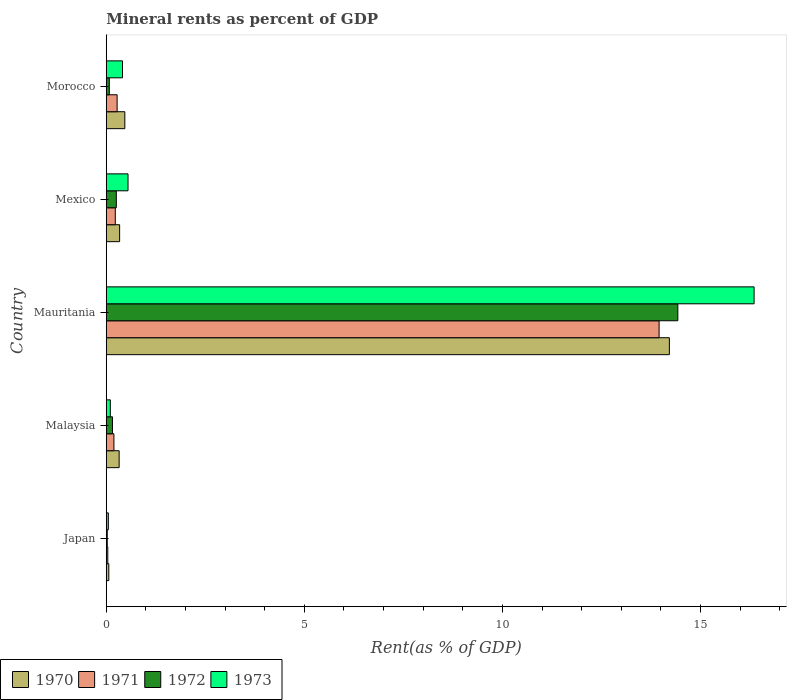How many groups of bars are there?
Offer a very short reply. 5. What is the label of the 5th group of bars from the top?
Your response must be concise. Japan. In how many cases, is the number of bars for a given country not equal to the number of legend labels?
Your response must be concise. 0. What is the mineral rent in 1970 in Japan?
Offer a very short reply. 0.06. Across all countries, what is the maximum mineral rent in 1971?
Provide a short and direct response. 13.95. Across all countries, what is the minimum mineral rent in 1972?
Offer a terse response. 0.03. In which country was the mineral rent in 1971 maximum?
Make the answer very short. Mauritania. In which country was the mineral rent in 1972 minimum?
Provide a succinct answer. Japan. What is the total mineral rent in 1971 in the graph?
Offer a terse response. 14.69. What is the difference between the mineral rent in 1970 in Mauritania and that in Morocco?
Your response must be concise. 13.74. What is the difference between the mineral rent in 1971 in Morocco and the mineral rent in 1970 in Japan?
Provide a short and direct response. 0.21. What is the average mineral rent in 1972 per country?
Provide a succinct answer. 2.99. What is the difference between the mineral rent in 1973 and mineral rent in 1972 in Mauritania?
Give a very brief answer. 1.93. In how many countries, is the mineral rent in 1972 greater than 8 %?
Provide a short and direct response. 1. What is the ratio of the mineral rent in 1972 in Malaysia to that in Morocco?
Keep it short and to the point. 2.05. What is the difference between the highest and the second highest mineral rent in 1970?
Keep it short and to the point. 13.74. What is the difference between the highest and the lowest mineral rent in 1970?
Make the answer very short. 14.15. In how many countries, is the mineral rent in 1973 greater than the average mineral rent in 1973 taken over all countries?
Provide a succinct answer. 1. Is it the case that in every country, the sum of the mineral rent in 1972 and mineral rent in 1970 is greater than the mineral rent in 1971?
Give a very brief answer. Yes. How many countries are there in the graph?
Give a very brief answer. 5. Are the values on the major ticks of X-axis written in scientific E-notation?
Offer a very short reply. No. Does the graph contain grids?
Your answer should be compact. No. How many legend labels are there?
Your answer should be very brief. 4. How are the legend labels stacked?
Provide a short and direct response. Horizontal. What is the title of the graph?
Ensure brevity in your answer.  Mineral rents as percent of GDP. What is the label or title of the X-axis?
Make the answer very short. Rent(as % of GDP). What is the label or title of the Y-axis?
Provide a short and direct response. Country. What is the Rent(as % of GDP) in 1970 in Japan?
Give a very brief answer. 0.06. What is the Rent(as % of GDP) in 1971 in Japan?
Your response must be concise. 0.04. What is the Rent(as % of GDP) in 1972 in Japan?
Offer a very short reply. 0.03. What is the Rent(as % of GDP) in 1973 in Japan?
Ensure brevity in your answer.  0.05. What is the Rent(as % of GDP) in 1970 in Malaysia?
Your answer should be very brief. 0.33. What is the Rent(as % of GDP) of 1971 in Malaysia?
Provide a succinct answer. 0.19. What is the Rent(as % of GDP) in 1972 in Malaysia?
Your answer should be very brief. 0.16. What is the Rent(as % of GDP) in 1973 in Malaysia?
Keep it short and to the point. 0.1. What is the Rent(as % of GDP) of 1970 in Mauritania?
Give a very brief answer. 14.21. What is the Rent(as % of GDP) in 1971 in Mauritania?
Your answer should be compact. 13.95. What is the Rent(as % of GDP) in 1972 in Mauritania?
Offer a terse response. 14.43. What is the Rent(as % of GDP) of 1973 in Mauritania?
Give a very brief answer. 16.35. What is the Rent(as % of GDP) in 1970 in Mexico?
Make the answer very short. 0.34. What is the Rent(as % of GDP) of 1971 in Mexico?
Offer a terse response. 0.23. What is the Rent(as % of GDP) in 1972 in Mexico?
Your answer should be compact. 0.25. What is the Rent(as % of GDP) of 1973 in Mexico?
Keep it short and to the point. 0.55. What is the Rent(as % of GDP) of 1970 in Morocco?
Your answer should be compact. 0.47. What is the Rent(as % of GDP) of 1971 in Morocco?
Provide a short and direct response. 0.27. What is the Rent(as % of GDP) of 1972 in Morocco?
Provide a short and direct response. 0.08. What is the Rent(as % of GDP) of 1973 in Morocco?
Provide a short and direct response. 0.41. Across all countries, what is the maximum Rent(as % of GDP) of 1970?
Provide a succinct answer. 14.21. Across all countries, what is the maximum Rent(as % of GDP) of 1971?
Keep it short and to the point. 13.95. Across all countries, what is the maximum Rent(as % of GDP) of 1972?
Provide a short and direct response. 14.43. Across all countries, what is the maximum Rent(as % of GDP) of 1973?
Offer a very short reply. 16.35. Across all countries, what is the minimum Rent(as % of GDP) of 1970?
Provide a succinct answer. 0.06. Across all countries, what is the minimum Rent(as % of GDP) of 1971?
Your response must be concise. 0.04. Across all countries, what is the minimum Rent(as % of GDP) in 1972?
Provide a short and direct response. 0.03. Across all countries, what is the minimum Rent(as % of GDP) in 1973?
Provide a short and direct response. 0.05. What is the total Rent(as % of GDP) of 1970 in the graph?
Provide a succinct answer. 15.41. What is the total Rent(as % of GDP) in 1971 in the graph?
Ensure brevity in your answer.  14.69. What is the total Rent(as % of GDP) in 1972 in the graph?
Make the answer very short. 14.94. What is the total Rent(as % of GDP) in 1973 in the graph?
Offer a very short reply. 17.47. What is the difference between the Rent(as % of GDP) of 1970 in Japan and that in Malaysia?
Give a very brief answer. -0.26. What is the difference between the Rent(as % of GDP) of 1971 in Japan and that in Malaysia?
Make the answer very short. -0.16. What is the difference between the Rent(as % of GDP) in 1972 in Japan and that in Malaysia?
Your answer should be very brief. -0.13. What is the difference between the Rent(as % of GDP) of 1973 in Japan and that in Malaysia?
Your answer should be very brief. -0.05. What is the difference between the Rent(as % of GDP) in 1970 in Japan and that in Mauritania?
Offer a terse response. -14.15. What is the difference between the Rent(as % of GDP) in 1971 in Japan and that in Mauritania?
Your answer should be compact. -13.91. What is the difference between the Rent(as % of GDP) in 1972 in Japan and that in Mauritania?
Your response must be concise. -14.4. What is the difference between the Rent(as % of GDP) of 1973 in Japan and that in Mauritania?
Offer a terse response. -16.3. What is the difference between the Rent(as % of GDP) in 1970 in Japan and that in Mexico?
Ensure brevity in your answer.  -0.27. What is the difference between the Rent(as % of GDP) of 1971 in Japan and that in Mexico?
Offer a very short reply. -0.19. What is the difference between the Rent(as % of GDP) of 1972 in Japan and that in Mexico?
Give a very brief answer. -0.23. What is the difference between the Rent(as % of GDP) in 1973 in Japan and that in Mexico?
Your response must be concise. -0.5. What is the difference between the Rent(as % of GDP) in 1970 in Japan and that in Morocco?
Give a very brief answer. -0.4. What is the difference between the Rent(as % of GDP) of 1971 in Japan and that in Morocco?
Make the answer very short. -0.24. What is the difference between the Rent(as % of GDP) of 1972 in Japan and that in Morocco?
Offer a very short reply. -0.05. What is the difference between the Rent(as % of GDP) in 1973 in Japan and that in Morocco?
Offer a terse response. -0.36. What is the difference between the Rent(as % of GDP) in 1970 in Malaysia and that in Mauritania?
Offer a very short reply. -13.89. What is the difference between the Rent(as % of GDP) of 1971 in Malaysia and that in Mauritania?
Provide a succinct answer. -13.76. What is the difference between the Rent(as % of GDP) of 1972 in Malaysia and that in Mauritania?
Provide a short and direct response. -14.27. What is the difference between the Rent(as % of GDP) of 1973 in Malaysia and that in Mauritania?
Your answer should be compact. -16.25. What is the difference between the Rent(as % of GDP) of 1970 in Malaysia and that in Mexico?
Your answer should be very brief. -0.01. What is the difference between the Rent(as % of GDP) in 1971 in Malaysia and that in Mexico?
Offer a very short reply. -0.03. What is the difference between the Rent(as % of GDP) of 1972 in Malaysia and that in Mexico?
Your answer should be very brief. -0.1. What is the difference between the Rent(as % of GDP) in 1973 in Malaysia and that in Mexico?
Make the answer very short. -0.45. What is the difference between the Rent(as % of GDP) in 1970 in Malaysia and that in Morocco?
Ensure brevity in your answer.  -0.14. What is the difference between the Rent(as % of GDP) of 1971 in Malaysia and that in Morocco?
Offer a very short reply. -0.08. What is the difference between the Rent(as % of GDP) of 1972 in Malaysia and that in Morocco?
Give a very brief answer. 0.08. What is the difference between the Rent(as % of GDP) in 1973 in Malaysia and that in Morocco?
Ensure brevity in your answer.  -0.31. What is the difference between the Rent(as % of GDP) of 1970 in Mauritania and that in Mexico?
Offer a very short reply. 13.88. What is the difference between the Rent(as % of GDP) in 1971 in Mauritania and that in Mexico?
Keep it short and to the point. 13.72. What is the difference between the Rent(as % of GDP) in 1972 in Mauritania and that in Mexico?
Offer a terse response. 14.17. What is the difference between the Rent(as % of GDP) in 1973 in Mauritania and that in Mexico?
Keep it short and to the point. 15.8. What is the difference between the Rent(as % of GDP) of 1970 in Mauritania and that in Morocco?
Ensure brevity in your answer.  13.74. What is the difference between the Rent(as % of GDP) in 1971 in Mauritania and that in Morocco?
Keep it short and to the point. 13.68. What is the difference between the Rent(as % of GDP) in 1972 in Mauritania and that in Morocco?
Your answer should be very brief. 14.35. What is the difference between the Rent(as % of GDP) in 1973 in Mauritania and that in Morocco?
Keep it short and to the point. 15.94. What is the difference between the Rent(as % of GDP) in 1970 in Mexico and that in Morocco?
Your answer should be compact. -0.13. What is the difference between the Rent(as % of GDP) of 1971 in Mexico and that in Morocco?
Ensure brevity in your answer.  -0.05. What is the difference between the Rent(as % of GDP) in 1972 in Mexico and that in Morocco?
Ensure brevity in your answer.  0.18. What is the difference between the Rent(as % of GDP) of 1973 in Mexico and that in Morocco?
Keep it short and to the point. 0.14. What is the difference between the Rent(as % of GDP) in 1970 in Japan and the Rent(as % of GDP) in 1971 in Malaysia?
Your answer should be very brief. -0.13. What is the difference between the Rent(as % of GDP) in 1970 in Japan and the Rent(as % of GDP) in 1972 in Malaysia?
Provide a succinct answer. -0.09. What is the difference between the Rent(as % of GDP) in 1970 in Japan and the Rent(as % of GDP) in 1973 in Malaysia?
Keep it short and to the point. -0.04. What is the difference between the Rent(as % of GDP) in 1971 in Japan and the Rent(as % of GDP) in 1972 in Malaysia?
Offer a very short reply. -0.12. What is the difference between the Rent(as % of GDP) of 1971 in Japan and the Rent(as % of GDP) of 1973 in Malaysia?
Provide a succinct answer. -0.06. What is the difference between the Rent(as % of GDP) of 1972 in Japan and the Rent(as % of GDP) of 1973 in Malaysia?
Give a very brief answer. -0.08. What is the difference between the Rent(as % of GDP) in 1970 in Japan and the Rent(as % of GDP) in 1971 in Mauritania?
Make the answer very short. -13.89. What is the difference between the Rent(as % of GDP) of 1970 in Japan and the Rent(as % of GDP) of 1972 in Mauritania?
Give a very brief answer. -14.36. What is the difference between the Rent(as % of GDP) in 1970 in Japan and the Rent(as % of GDP) in 1973 in Mauritania?
Provide a succinct answer. -16.29. What is the difference between the Rent(as % of GDP) in 1971 in Japan and the Rent(as % of GDP) in 1972 in Mauritania?
Keep it short and to the point. -14.39. What is the difference between the Rent(as % of GDP) of 1971 in Japan and the Rent(as % of GDP) of 1973 in Mauritania?
Offer a very short reply. -16.31. What is the difference between the Rent(as % of GDP) of 1972 in Japan and the Rent(as % of GDP) of 1973 in Mauritania?
Make the answer very short. -16.33. What is the difference between the Rent(as % of GDP) of 1970 in Japan and the Rent(as % of GDP) of 1971 in Mexico?
Give a very brief answer. -0.16. What is the difference between the Rent(as % of GDP) in 1970 in Japan and the Rent(as % of GDP) in 1972 in Mexico?
Keep it short and to the point. -0.19. What is the difference between the Rent(as % of GDP) in 1970 in Japan and the Rent(as % of GDP) in 1973 in Mexico?
Your response must be concise. -0.48. What is the difference between the Rent(as % of GDP) of 1971 in Japan and the Rent(as % of GDP) of 1972 in Mexico?
Provide a short and direct response. -0.22. What is the difference between the Rent(as % of GDP) in 1971 in Japan and the Rent(as % of GDP) in 1973 in Mexico?
Make the answer very short. -0.51. What is the difference between the Rent(as % of GDP) in 1972 in Japan and the Rent(as % of GDP) in 1973 in Mexico?
Your response must be concise. -0.52. What is the difference between the Rent(as % of GDP) in 1970 in Japan and the Rent(as % of GDP) in 1971 in Morocco?
Ensure brevity in your answer.  -0.21. What is the difference between the Rent(as % of GDP) in 1970 in Japan and the Rent(as % of GDP) in 1972 in Morocco?
Ensure brevity in your answer.  -0.01. What is the difference between the Rent(as % of GDP) of 1970 in Japan and the Rent(as % of GDP) of 1973 in Morocco?
Provide a short and direct response. -0.35. What is the difference between the Rent(as % of GDP) in 1971 in Japan and the Rent(as % of GDP) in 1972 in Morocco?
Give a very brief answer. -0.04. What is the difference between the Rent(as % of GDP) in 1971 in Japan and the Rent(as % of GDP) in 1973 in Morocco?
Provide a short and direct response. -0.37. What is the difference between the Rent(as % of GDP) in 1972 in Japan and the Rent(as % of GDP) in 1973 in Morocco?
Give a very brief answer. -0.39. What is the difference between the Rent(as % of GDP) in 1970 in Malaysia and the Rent(as % of GDP) in 1971 in Mauritania?
Offer a terse response. -13.63. What is the difference between the Rent(as % of GDP) in 1970 in Malaysia and the Rent(as % of GDP) in 1972 in Mauritania?
Your answer should be very brief. -14.1. What is the difference between the Rent(as % of GDP) in 1970 in Malaysia and the Rent(as % of GDP) in 1973 in Mauritania?
Your answer should be compact. -16.03. What is the difference between the Rent(as % of GDP) of 1971 in Malaysia and the Rent(as % of GDP) of 1972 in Mauritania?
Your response must be concise. -14.23. What is the difference between the Rent(as % of GDP) in 1971 in Malaysia and the Rent(as % of GDP) in 1973 in Mauritania?
Keep it short and to the point. -16.16. What is the difference between the Rent(as % of GDP) in 1972 in Malaysia and the Rent(as % of GDP) in 1973 in Mauritania?
Provide a short and direct response. -16.19. What is the difference between the Rent(as % of GDP) in 1970 in Malaysia and the Rent(as % of GDP) in 1971 in Mexico?
Offer a very short reply. 0.1. What is the difference between the Rent(as % of GDP) of 1970 in Malaysia and the Rent(as % of GDP) of 1972 in Mexico?
Give a very brief answer. 0.07. What is the difference between the Rent(as % of GDP) of 1970 in Malaysia and the Rent(as % of GDP) of 1973 in Mexico?
Provide a short and direct response. -0.22. What is the difference between the Rent(as % of GDP) of 1971 in Malaysia and the Rent(as % of GDP) of 1972 in Mexico?
Your response must be concise. -0.06. What is the difference between the Rent(as % of GDP) of 1971 in Malaysia and the Rent(as % of GDP) of 1973 in Mexico?
Offer a terse response. -0.36. What is the difference between the Rent(as % of GDP) in 1972 in Malaysia and the Rent(as % of GDP) in 1973 in Mexico?
Offer a terse response. -0.39. What is the difference between the Rent(as % of GDP) in 1970 in Malaysia and the Rent(as % of GDP) in 1971 in Morocco?
Provide a short and direct response. 0.05. What is the difference between the Rent(as % of GDP) of 1970 in Malaysia and the Rent(as % of GDP) of 1972 in Morocco?
Provide a succinct answer. 0.25. What is the difference between the Rent(as % of GDP) in 1970 in Malaysia and the Rent(as % of GDP) in 1973 in Morocco?
Give a very brief answer. -0.09. What is the difference between the Rent(as % of GDP) of 1971 in Malaysia and the Rent(as % of GDP) of 1972 in Morocco?
Provide a short and direct response. 0.12. What is the difference between the Rent(as % of GDP) of 1971 in Malaysia and the Rent(as % of GDP) of 1973 in Morocco?
Your answer should be compact. -0.22. What is the difference between the Rent(as % of GDP) of 1972 in Malaysia and the Rent(as % of GDP) of 1973 in Morocco?
Provide a short and direct response. -0.25. What is the difference between the Rent(as % of GDP) of 1970 in Mauritania and the Rent(as % of GDP) of 1971 in Mexico?
Provide a succinct answer. 13.98. What is the difference between the Rent(as % of GDP) in 1970 in Mauritania and the Rent(as % of GDP) in 1972 in Mexico?
Provide a succinct answer. 13.96. What is the difference between the Rent(as % of GDP) of 1970 in Mauritania and the Rent(as % of GDP) of 1973 in Mexico?
Your answer should be very brief. 13.66. What is the difference between the Rent(as % of GDP) in 1971 in Mauritania and the Rent(as % of GDP) in 1972 in Mexico?
Offer a terse response. 13.7. What is the difference between the Rent(as % of GDP) of 1971 in Mauritania and the Rent(as % of GDP) of 1973 in Mexico?
Your response must be concise. 13.4. What is the difference between the Rent(as % of GDP) of 1972 in Mauritania and the Rent(as % of GDP) of 1973 in Mexico?
Ensure brevity in your answer.  13.88. What is the difference between the Rent(as % of GDP) in 1970 in Mauritania and the Rent(as % of GDP) in 1971 in Morocco?
Your response must be concise. 13.94. What is the difference between the Rent(as % of GDP) of 1970 in Mauritania and the Rent(as % of GDP) of 1972 in Morocco?
Your answer should be compact. 14.14. What is the difference between the Rent(as % of GDP) of 1970 in Mauritania and the Rent(as % of GDP) of 1973 in Morocco?
Make the answer very short. 13.8. What is the difference between the Rent(as % of GDP) in 1971 in Mauritania and the Rent(as % of GDP) in 1972 in Morocco?
Provide a short and direct response. 13.88. What is the difference between the Rent(as % of GDP) in 1971 in Mauritania and the Rent(as % of GDP) in 1973 in Morocco?
Your answer should be very brief. 13.54. What is the difference between the Rent(as % of GDP) in 1972 in Mauritania and the Rent(as % of GDP) in 1973 in Morocco?
Provide a short and direct response. 14.02. What is the difference between the Rent(as % of GDP) of 1970 in Mexico and the Rent(as % of GDP) of 1971 in Morocco?
Your answer should be very brief. 0.06. What is the difference between the Rent(as % of GDP) in 1970 in Mexico and the Rent(as % of GDP) in 1972 in Morocco?
Make the answer very short. 0.26. What is the difference between the Rent(as % of GDP) in 1970 in Mexico and the Rent(as % of GDP) in 1973 in Morocco?
Your response must be concise. -0.07. What is the difference between the Rent(as % of GDP) in 1971 in Mexico and the Rent(as % of GDP) in 1972 in Morocco?
Ensure brevity in your answer.  0.15. What is the difference between the Rent(as % of GDP) in 1971 in Mexico and the Rent(as % of GDP) in 1973 in Morocco?
Keep it short and to the point. -0.18. What is the difference between the Rent(as % of GDP) of 1972 in Mexico and the Rent(as % of GDP) of 1973 in Morocco?
Your response must be concise. -0.16. What is the average Rent(as % of GDP) of 1970 per country?
Provide a short and direct response. 3.08. What is the average Rent(as % of GDP) in 1971 per country?
Your response must be concise. 2.94. What is the average Rent(as % of GDP) in 1972 per country?
Your answer should be compact. 2.99. What is the average Rent(as % of GDP) in 1973 per country?
Keep it short and to the point. 3.49. What is the difference between the Rent(as % of GDP) in 1970 and Rent(as % of GDP) in 1971 in Japan?
Give a very brief answer. 0.03. What is the difference between the Rent(as % of GDP) in 1970 and Rent(as % of GDP) in 1972 in Japan?
Provide a short and direct response. 0.04. What is the difference between the Rent(as % of GDP) of 1970 and Rent(as % of GDP) of 1973 in Japan?
Your answer should be very brief. 0.01. What is the difference between the Rent(as % of GDP) in 1971 and Rent(as % of GDP) in 1972 in Japan?
Give a very brief answer. 0.01. What is the difference between the Rent(as % of GDP) of 1971 and Rent(as % of GDP) of 1973 in Japan?
Your answer should be very brief. -0.01. What is the difference between the Rent(as % of GDP) in 1972 and Rent(as % of GDP) in 1973 in Japan?
Give a very brief answer. -0.03. What is the difference between the Rent(as % of GDP) of 1970 and Rent(as % of GDP) of 1971 in Malaysia?
Provide a short and direct response. 0.13. What is the difference between the Rent(as % of GDP) of 1970 and Rent(as % of GDP) of 1972 in Malaysia?
Give a very brief answer. 0.17. What is the difference between the Rent(as % of GDP) of 1970 and Rent(as % of GDP) of 1973 in Malaysia?
Your answer should be compact. 0.22. What is the difference between the Rent(as % of GDP) of 1971 and Rent(as % of GDP) of 1972 in Malaysia?
Offer a very short reply. 0.04. What is the difference between the Rent(as % of GDP) of 1971 and Rent(as % of GDP) of 1973 in Malaysia?
Ensure brevity in your answer.  0.09. What is the difference between the Rent(as % of GDP) of 1972 and Rent(as % of GDP) of 1973 in Malaysia?
Your answer should be very brief. 0.05. What is the difference between the Rent(as % of GDP) in 1970 and Rent(as % of GDP) in 1971 in Mauritania?
Make the answer very short. 0.26. What is the difference between the Rent(as % of GDP) in 1970 and Rent(as % of GDP) in 1972 in Mauritania?
Provide a short and direct response. -0.21. What is the difference between the Rent(as % of GDP) of 1970 and Rent(as % of GDP) of 1973 in Mauritania?
Offer a very short reply. -2.14. What is the difference between the Rent(as % of GDP) in 1971 and Rent(as % of GDP) in 1972 in Mauritania?
Offer a very short reply. -0.47. What is the difference between the Rent(as % of GDP) of 1971 and Rent(as % of GDP) of 1973 in Mauritania?
Ensure brevity in your answer.  -2.4. What is the difference between the Rent(as % of GDP) of 1972 and Rent(as % of GDP) of 1973 in Mauritania?
Offer a very short reply. -1.93. What is the difference between the Rent(as % of GDP) of 1970 and Rent(as % of GDP) of 1971 in Mexico?
Keep it short and to the point. 0.11. What is the difference between the Rent(as % of GDP) in 1970 and Rent(as % of GDP) in 1972 in Mexico?
Give a very brief answer. 0.08. What is the difference between the Rent(as % of GDP) of 1970 and Rent(as % of GDP) of 1973 in Mexico?
Provide a short and direct response. -0.21. What is the difference between the Rent(as % of GDP) of 1971 and Rent(as % of GDP) of 1972 in Mexico?
Offer a terse response. -0.03. What is the difference between the Rent(as % of GDP) in 1971 and Rent(as % of GDP) in 1973 in Mexico?
Provide a succinct answer. -0.32. What is the difference between the Rent(as % of GDP) in 1972 and Rent(as % of GDP) in 1973 in Mexico?
Make the answer very short. -0.3. What is the difference between the Rent(as % of GDP) in 1970 and Rent(as % of GDP) in 1971 in Morocco?
Give a very brief answer. 0.19. What is the difference between the Rent(as % of GDP) in 1970 and Rent(as % of GDP) in 1972 in Morocco?
Your response must be concise. 0.39. What is the difference between the Rent(as % of GDP) in 1970 and Rent(as % of GDP) in 1973 in Morocco?
Your response must be concise. 0.06. What is the difference between the Rent(as % of GDP) of 1971 and Rent(as % of GDP) of 1972 in Morocco?
Your answer should be very brief. 0.2. What is the difference between the Rent(as % of GDP) in 1971 and Rent(as % of GDP) in 1973 in Morocco?
Make the answer very short. -0.14. What is the difference between the Rent(as % of GDP) in 1972 and Rent(as % of GDP) in 1973 in Morocco?
Your answer should be very brief. -0.33. What is the ratio of the Rent(as % of GDP) in 1970 in Japan to that in Malaysia?
Your answer should be very brief. 0.2. What is the ratio of the Rent(as % of GDP) in 1971 in Japan to that in Malaysia?
Your answer should be very brief. 0.2. What is the ratio of the Rent(as % of GDP) in 1972 in Japan to that in Malaysia?
Make the answer very short. 0.16. What is the ratio of the Rent(as % of GDP) in 1973 in Japan to that in Malaysia?
Make the answer very short. 0.51. What is the ratio of the Rent(as % of GDP) of 1970 in Japan to that in Mauritania?
Provide a short and direct response. 0. What is the ratio of the Rent(as % of GDP) in 1971 in Japan to that in Mauritania?
Offer a terse response. 0. What is the ratio of the Rent(as % of GDP) of 1972 in Japan to that in Mauritania?
Give a very brief answer. 0. What is the ratio of the Rent(as % of GDP) in 1973 in Japan to that in Mauritania?
Your answer should be very brief. 0. What is the ratio of the Rent(as % of GDP) in 1970 in Japan to that in Mexico?
Provide a short and direct response. 0.19. What is the ratio of the Rent(as % of GDP) of 1971 in Japan to that in Mexico?
Provide a short and direct response. 0.17. What is the ratio of the Rent(as % of GDP) of 1972 in Japan to that in Mexico?
Your response must be concise. 0.1. What is the ratio of the Rent(as % of GDP) in 1973 in Japan to that in Mexico?
Your answer should be very brief. 0.1. What is the ratio of the Rent(as % of GDP) in 1970 in Japan to that in Morocco?
Offer a terse response. 0.14. What is the ratio of the Rent(as % of GDP) in 1971 in Japan to that in Morocco?
Keep it short and to the point. 0.14. What is the ratio of the Rent(as % of GDP) of 1972 in Japan to that in Morocco?
Keep it short and to the point. 0.33. What is the ratio of the Rent(as % of GDP) of 1973 in Japan to that in Morocco?
Make the answer very short. 0.13. What is the ratio of the Rent(as % of GDP) of 1970 in Malaysia to that in Mauritania?
Your response must be concise. 0.02. What is the ratio of the Rent(as % of GDP) of 1971 in Malaysia to that in Mauritania?
Make the answer very short. 0.01. What is the ratio of the Rent(as % of GDP) in 1972 in Malaysia to that in Mauritania?
Make the answer very short. 0.01. What is the ratio of the Rent(as % of GDP) of 1973 in Malaysia to that in Mauritania?
Keep it short and to the point. 0.01. What is the ratio of the Rent(as % of GDP) in 1970 in Malaysia to that in Mexico?
Keep it short and to the point. 0.96. What is the ratio of the Rent(as % of GDP) in 1971 in Malaysia to that in Mexico?
Make the answer very short. 0.85. What is the ratio of the Rent(as % of GDP) of 1972 in Malaysia to that in Mexico?
Your answer should be very brief. 0.62. What is the ratio of the Rent(as % of GDP) of 1973 in Malaysia to that in Mexico?
Ensure brevity in your answer.  0.19. What is the ratio of the Rent(as % of GDP) of 1970 in Malaysia to that in Morocco?
Your answer should be very brief. 0.69. What is the ratio of the Rent(as % of GDP) of 1971 in Malaysia to that in Morocco?
Ensure brevity in your answer.  0.71. What is the ratio of the Rent(as % of GDP) in 1972 in Malaysia to that in Morocco?
Provide a succinct answer. 2.04. What is the ratio of the Rent(as % of GDP) in 1973 in Malaysia to that in Morocco?
Give a very brief answer. 0.25. What is the ratio of the Rent(as % of GDP) in 1970 in Mauritania to that in Mexico?
Your answer should be compact. 42.1. What is the ratio of the Rent(as % of GDP) of 1971 in Mauritania to that in Mexico?
Offer a very short reply. 61.1. What is the ratio of the Rent(as % of GDP) in 1972 in Mauritania to that in Mexico?
Give a very brief answer. 56.78. What is the ratio of the Rent(as % of GDP) of 1973 in Mauritania to that in Mexico?
Make the answer very short. 29.75. What is the ratio of the Rent(as % of GDP) in 1970 in Mauritania to that in Morocco?
Offer a terse response. 30.32. What is the ratio of the Rent(as % of GDP) in 1971 in Mauritania to that in Morocco?
Provide a short and direct response. 50.9. What is the ratio of the Rent(as % of GDP) in 1972 in Mauritania to that in Morocco?
Provide a short and direct response. 187.82. What is the ratio of the Rent(as % of GDP) of 1973 in Mauritania to that in Morocco?
Offer a very short reply. 39.85. What is the ratio of the Rent(as % of GDP) in 1970 in Mexico to that in Morocco?
Offer a terse response. 0.72. What is the ratio of the Rent(as % of GDP) in 1971 in Mexico to that in Morocco?
Keep it short and to the point. 0.83. What is the ratio of the Rent(as % of GDP) of 1972 in Mexico to that in Morocco?
Make the answer very short. 3.31. What is the ratio of the Rent(as % of GDP) in 1973 in Mexico to that in Morocco?
Give a very brief answer. 1.34. What is the difference between the highest and the second highest Rent(as % of GDP) of 1970?
Keep it short and to the point. 13.74. What is the difference between the highest and the second highest Rent(as % of GDP) in 1971?
Offer a terse response. 13.68. What is the difference between the highest and the second highest Rent(as % of GDP) in 1972?
Provide a short and direct response. 14.17. What is the difference between the highest and the second highest Rent(as % of GDP) of 1973?
Give a very brief answer. 15.8. What is the difference between the highest and the lowest Rent(as % of GDP) of 1970?
Make the answer very short. 14.15. What is the difference between the highest and the lowest Rent(as % of GDP) of 1971?
Your answer should be compact. 13.91. What is the difference between the highest and the lowest Rent(as % of GDP) in 1972?
Keep it short and to the point. 14.4. What is the difference between the highest and the lowest Rent(as % of GDP) in 1973?
Your answer should be very brief. 16.3. 